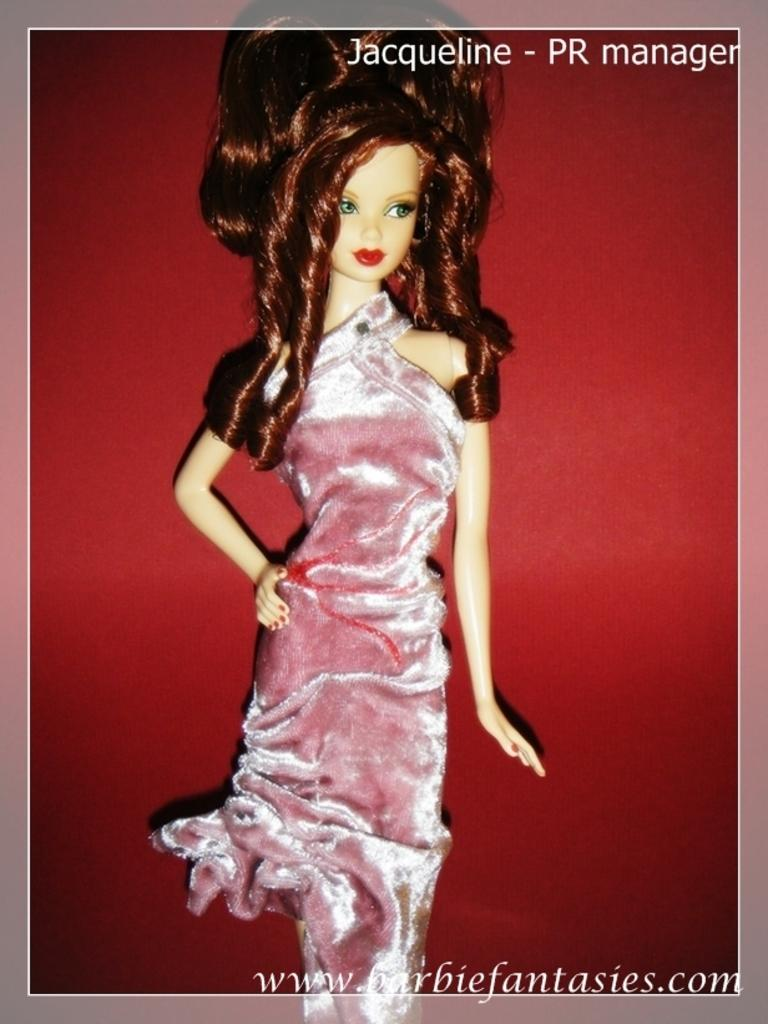What is the main subject of the image? There is a doll in the image. What material is used for the doll's clothing? The doll has a velvet cloth. Can you describe any imperfections in the image? There are watermarks in the right corners of the image. What color is the wall in the background of the image? There is a red wall in the background of the image. What type of expert advice is being given in the image? There is no expert or advice present in the image; it features a doll with a velvet cloth and a red wall in the background. Can you tell me how many sea creatures are visible in the image? There are no sea creatures present in the image. 